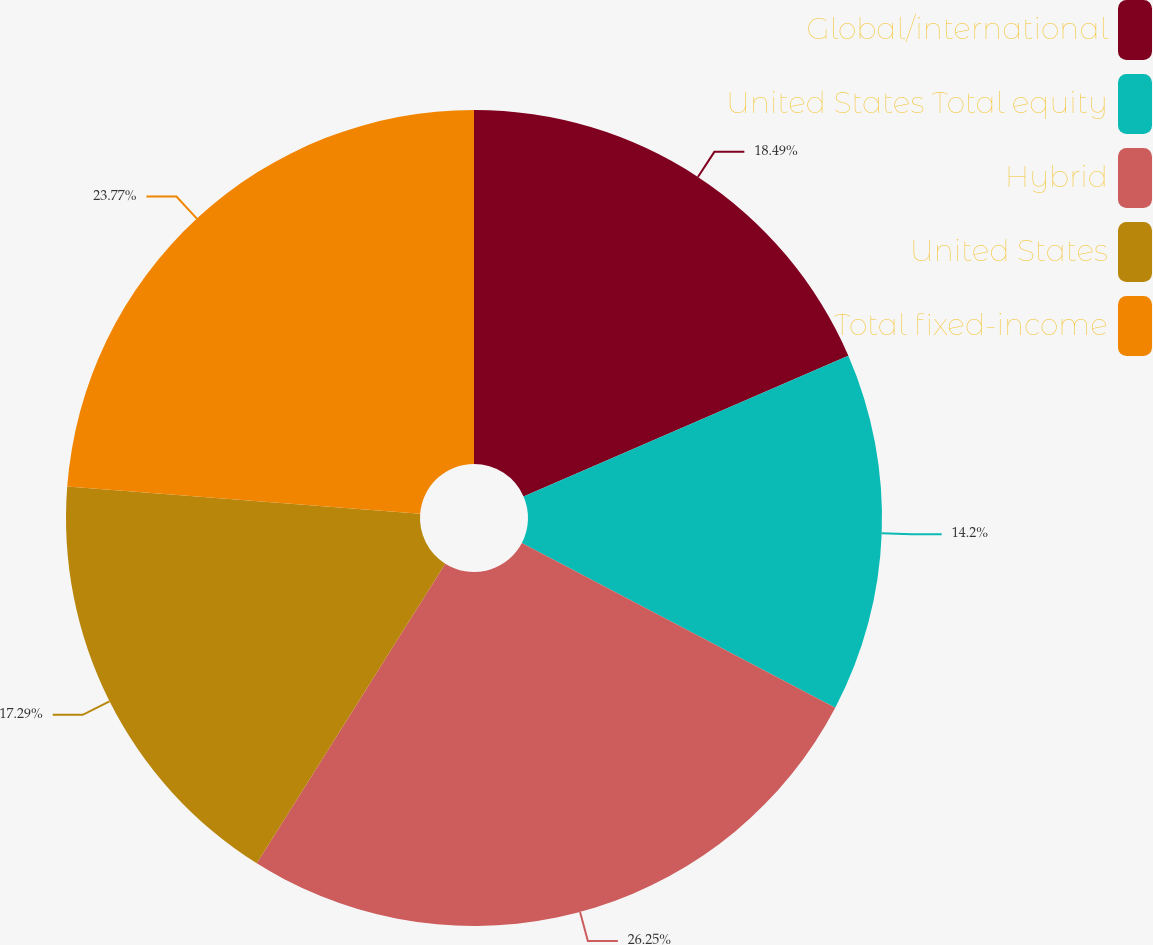Convert chart to OTSL. <chart><loc_0><loc_0><loc_500><loc_500><pie_chart><fcel>Global/international<fcel>United States Total equity<fcel>Hybrid<fcel>United States<fcel>Total fixed-income<nl><fcel>18.49%<fcel>14.2%<fcel>26.24%<fcel>17.29%<fcel>23.77%<nl></chart> 